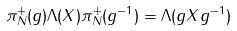<formula> <loc_0><loc_0><loc_500><loc_500>\pi ^ { + } _ { N } ( g ) \Lambda ( X ) \pi ^ { + } _ { N } ( g ^ { - 1 } ) = \Lambda ( g X g ^ { - 1 } )</formula> 